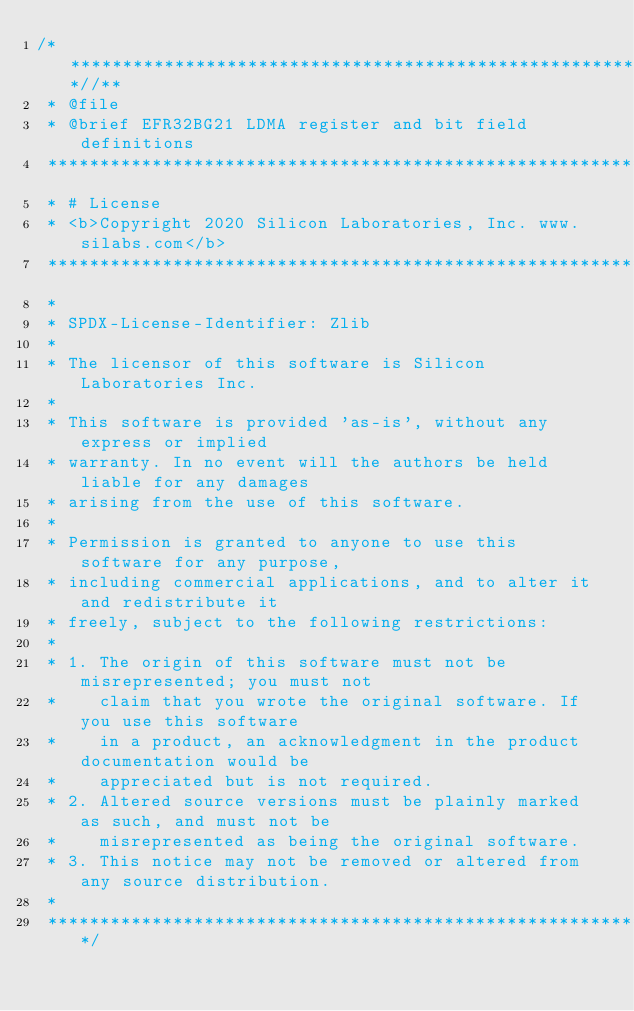Convert code to text. <code><loc_0><loc_0><loc_500><loc_500><_C_>/**************************************************************************//**
 * @file
 * @brief EFR32BG21 LDMA register and bit field definitions
 ******************************************************************************
 * # License
 * <b>Copyright 2020 Silicon Laboratories, Inc. www.silabs.com</b>
 ******************************************************************************
 *
 * SPDX-License-Identifier: Zlib
 *
 * The licensor of this software is Silicon Laboratories Inc.
 *
 * This software is provided 'as-is', without any express or implied
 * warranty. In no event will the authors be held liable for any damages
 * arising from the use of this software.
 *
 * Permission is granted to anyone to use this software for any purpose,
 * including commercial applications, and to alter it and redistribute it
 * freely, subject to the following restrictions:
 *
 * 1. The origin of this software must not be misrepresented; you must not
 *    claim that you wrote the original software. If you use this software
 *    in a product, an acknowledgment in the product documentation would be
 *    appreciated but is not required.
 * 2. Altered source versions must be plainly marked as such, and must not be
 *    misrepresented as being the original software.
 * 3. This notice may not be removed or altered from any source distribution.
 *
 *****************************************************************************/</code> 